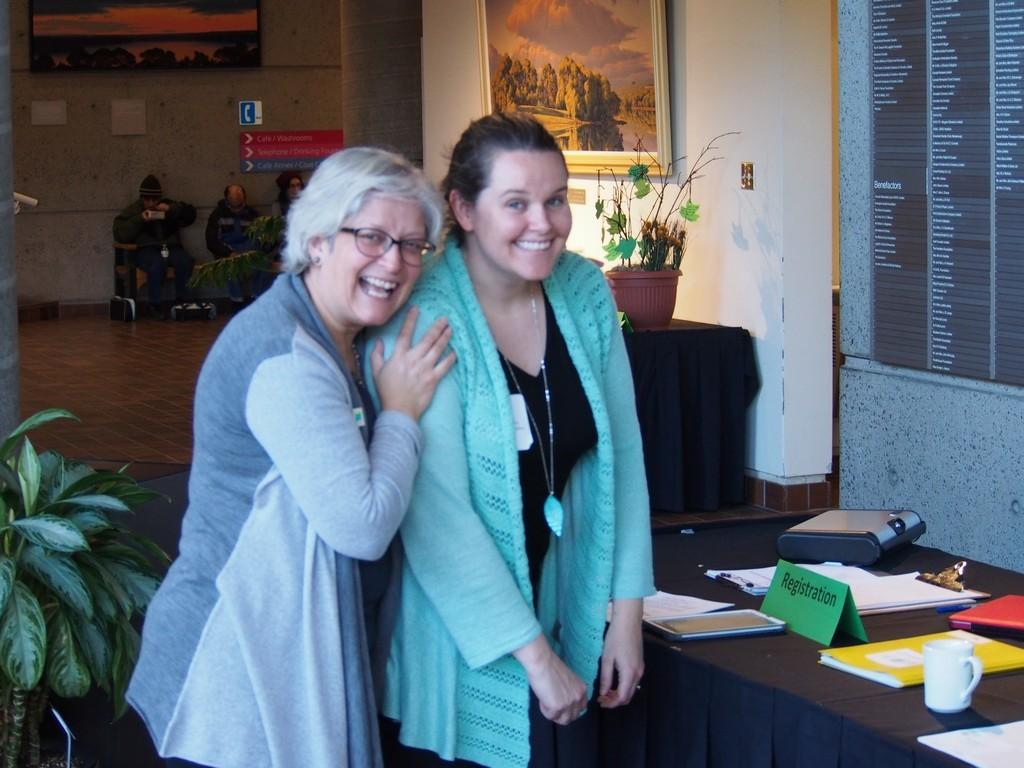How many women are present in the image? There are two women in the image. What expression do the women have? The women are smiling. What is located in the image besides the women? There is a table, objects on the table, a plant, and a wall in the image. What type of liquid can be seen flowing from the minister's nose in the image? There is no minister or liquid flowing from anyone's nose in the image. 